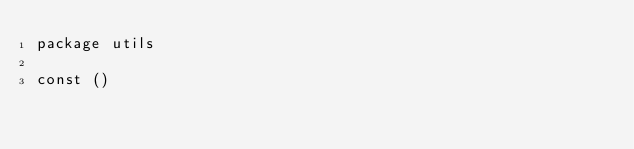<code> <loc_0><loc_0><loc_500><loc_500><_Go_>package utils

const ()
</code> 